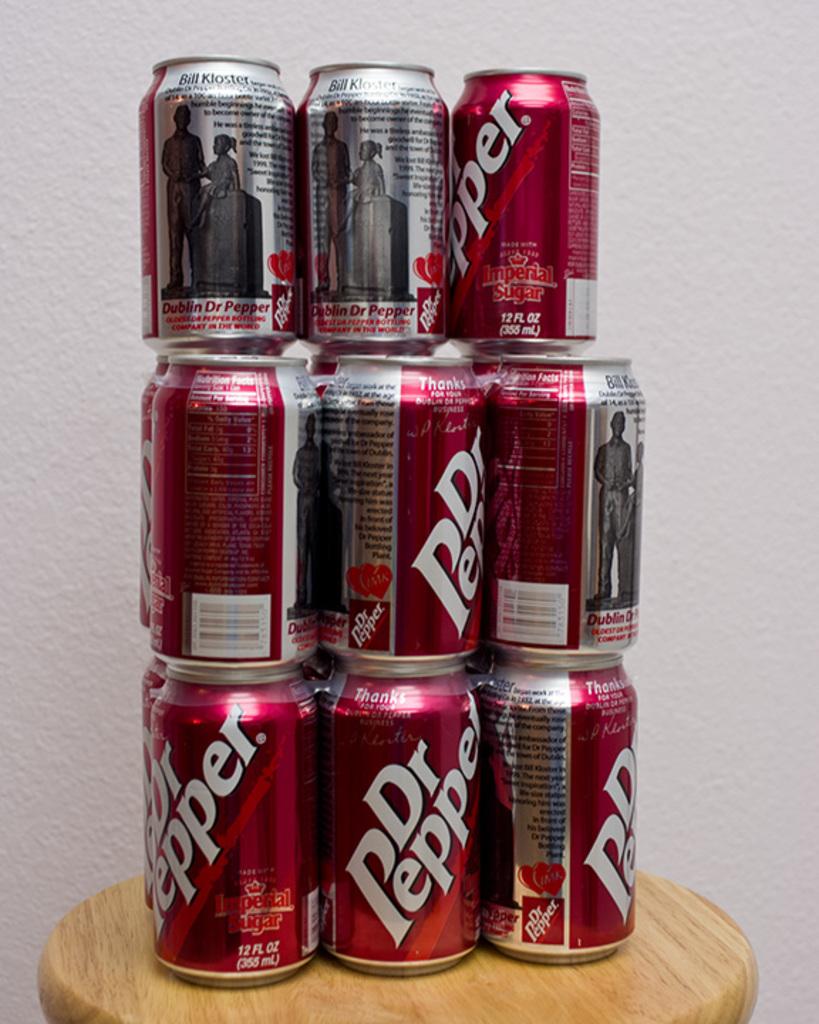What brand of soda are the stack of cans?
Offer a very short reply. Dr pepper. How many ounces are in each can?
Your response must be concise. 12. 